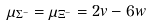<formula> <loc_0><loc_0><loc_500><loc_500>\mu _ { \Sigma ^ { - } } = \mu _ { \Xi ^ { - } } = 2 v - 6 w</formula> 